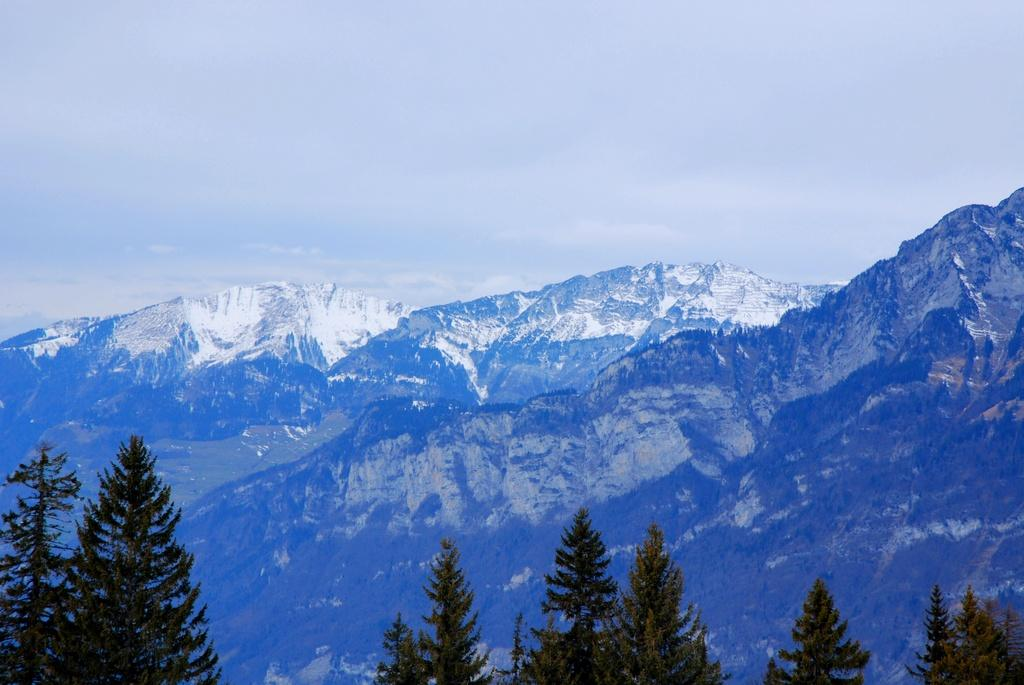What type of natural landform can be seen in the image? There are mountains in the image. What type of vegetation is present in the image? There are trees in the image. What is the weather like in the image? The sky is cloudy in the image, and there is snow visible, which suggests a cold and possibly snowy environment. Can you see a key hanging from one of the trees in the image? There is no key present in the image; it only features mountains, trees, snow, and a cloudy sky. 